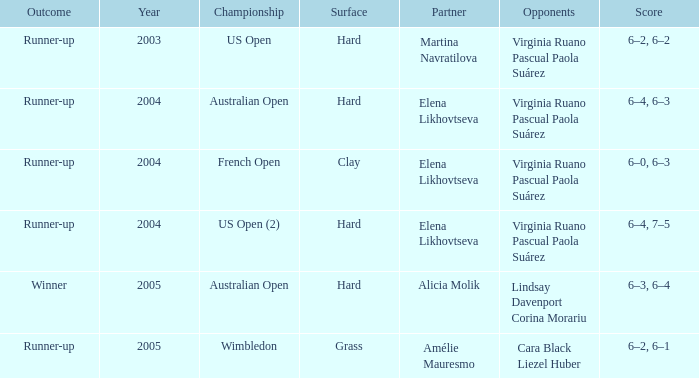When alicia molik is the partner what is the outcome? Winner. 